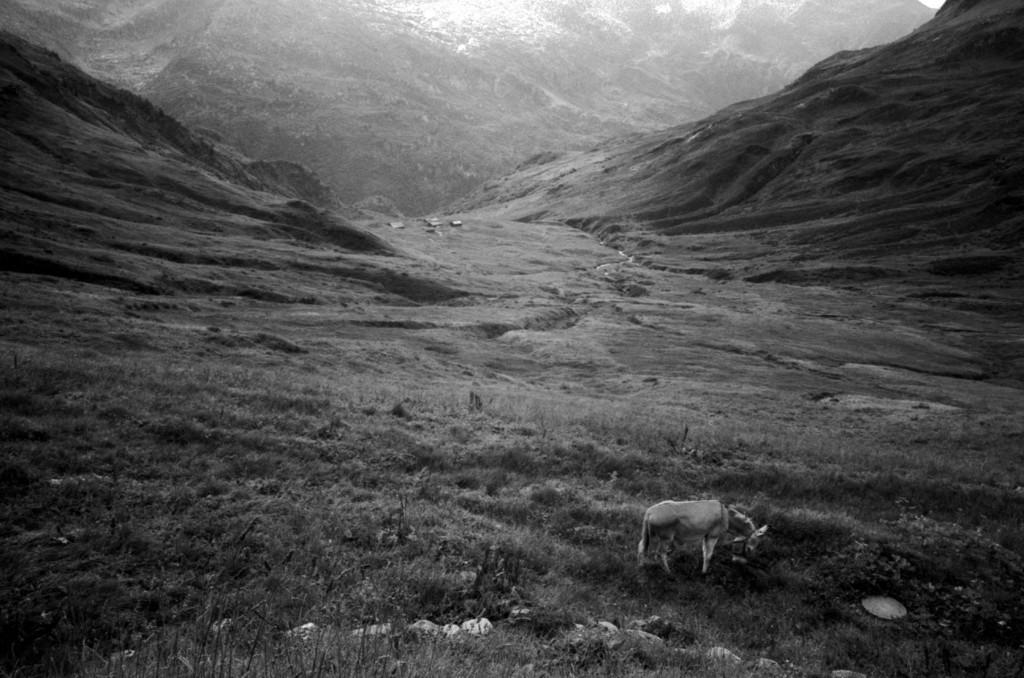What type of animal can be seen in the image? There is an animal standing in the front of the image. What is the ground covered with in the image? There is grass on the ground in the image. What can be seen in the distance in the image? There are mountains visible in the background of the image. What color is the brass eye of the animal in the image? There is no mention of brass or an eye in the provided facts, so we cannot determine the color of the animal's eye from the image. 